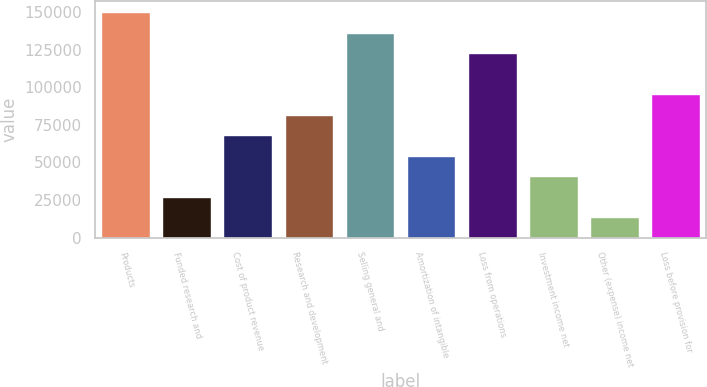Convert chart. <chart><loc_0><loc_0><loc_500><loc_500><bar_chart><fcel>Products<fcel>Funded research and<fcel>Cost of product revenue<fcel>Research and development<fcel>Selling general and<fcel>Amortization of intangible<fcel>Loss from operations<fcel>Investment income net<fcel>Other (expense) income net<fcel>Loss before provision for<nl><fcel>149801<fcel>27237.4<fcel>68092<fcel>81710.2<fcel>136183<fcel>54473.8<fcel>122565<fcel>40855.6<fcel>13619.2<fcel>95328.4<nl></chart> 